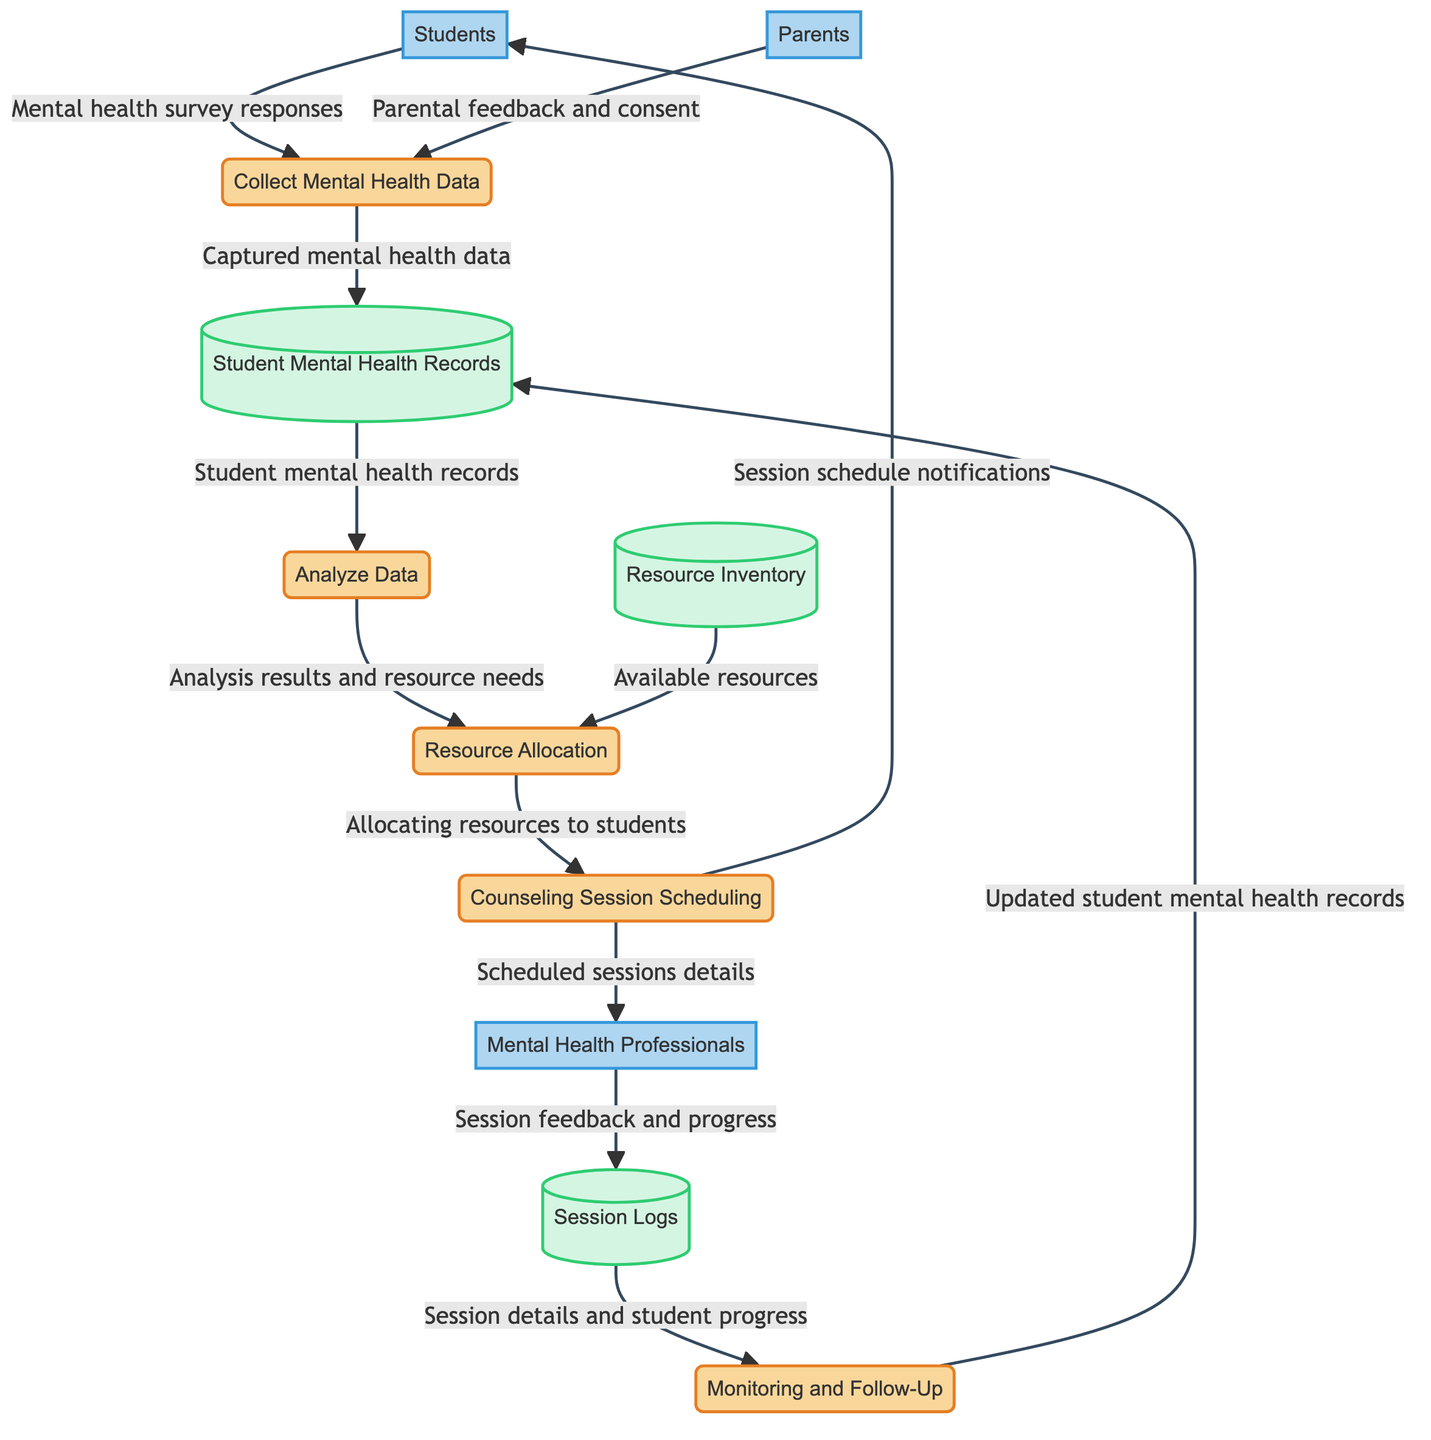What is the first process in the diagram? The first process listed in the "Processes" section is "Collect Mental Health Data." It is identified as P1 and is involved in gathering information from students.
Answer: Collect Mental Health Data How many external entities are there? The diagram lists three external entities: Students, Parents, and Mental Health Professionals. Thus, the count of external entities is three.
Answer: 3 What data flows from Parents to the Collect Mental Health Data process? According to the diagram, the data flowing from Parents to the Collect Mental Health Data process is "Parental feedback and consent." This indicates the nature of interaction at this step.
Answer: Parental feedback and consent Which process receives session details from Counseling Session Scheduling? The process that receives scheduled session details from Counseling Session Scheduling is Mental Health Professionals. This is indicated by the directed flow in the diagram.
Answer: Mental Health Professionals What type of records does the Monitoring and Follow-Up process update? The Monitoring and Follow-Up process updates "Student Mental Health Records" upon completing its monitoring efforts, as illustrated in the data flow to the datastore.
Answer: Student Mental Health Records Which process analyzes the data captured from Student Mental Health Records? The process that analyzes the data captured from the Student Mental Health Records is "Analyze Data." It takes the data stored in the respective datastore for further examination.
Answer: Analyze Data How many processes are sequentially linked between Analyze Data and Monitoring and Follow-Up? Analyzing the diagram, there are two processes linked sequentially: Resource Allocation and Monitoring and Follow-Up. Thus, the total is two processes.
Answer: 2 What type of data does the Resource Allocation process utilize? The Resource Allocation process utilizes "Analysis results and resource needs" along with available resources from the Resource Inventory. This includes critical decisions regarding mental health resources.
Answer: Analysis results and resource needs Which datastore maintains the records of all counseling sessions held? The "Session Logs" datastore maintains the records of all counseling sessions, capturing details such as student progress and feedback from mental health professionals.
Answer: Session Logs 